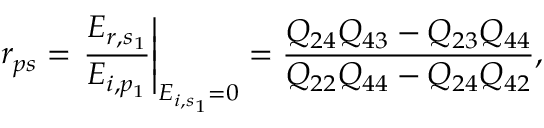Convert formula to latex. <formula><loc_0><loc_0><loc_500><loc_500>r _ { p s } = \frac { E _ { r , s _ { 1 } } } { E _ { i , p _ { 1 } } } \right | _ { E _ { i , s _ { 1 } } = 0 } = \frac { Q _ { 2 4 } Q _ { 4 3 } - Q _ { 2 3 } Q _ { 4 4 } } { Q _ { 2 2 } Q _ { 4 4 } - Q _ { 2 4 } Q _ { 4 2 } } ,</formula> 